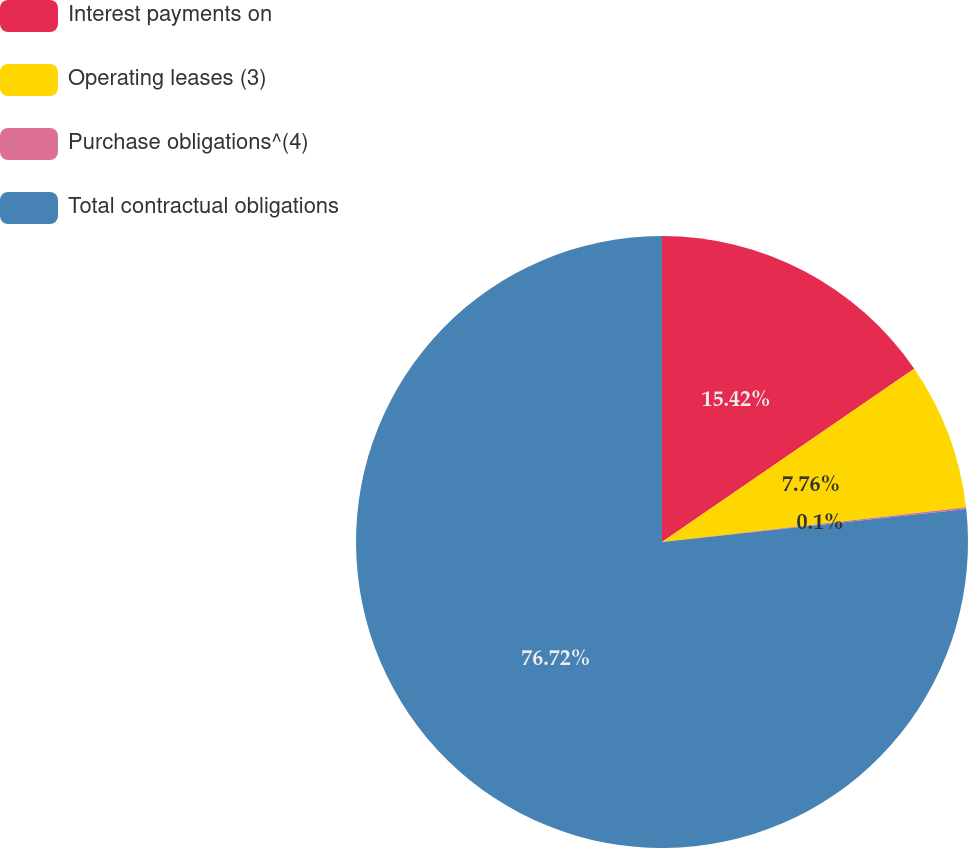Convert chart. <chart><loc_0><loc_0><loc_500><loc_500><pie_chart><fcel>Interest payments on<fcel>Operating leases (3)<fcel>Purchase obligations^(4)<fcel>Total contractual obligations<nl><fcel>15.42%<fcel>7.76%<fcel>0.1%<fcel>76.71%<nl></chart> 